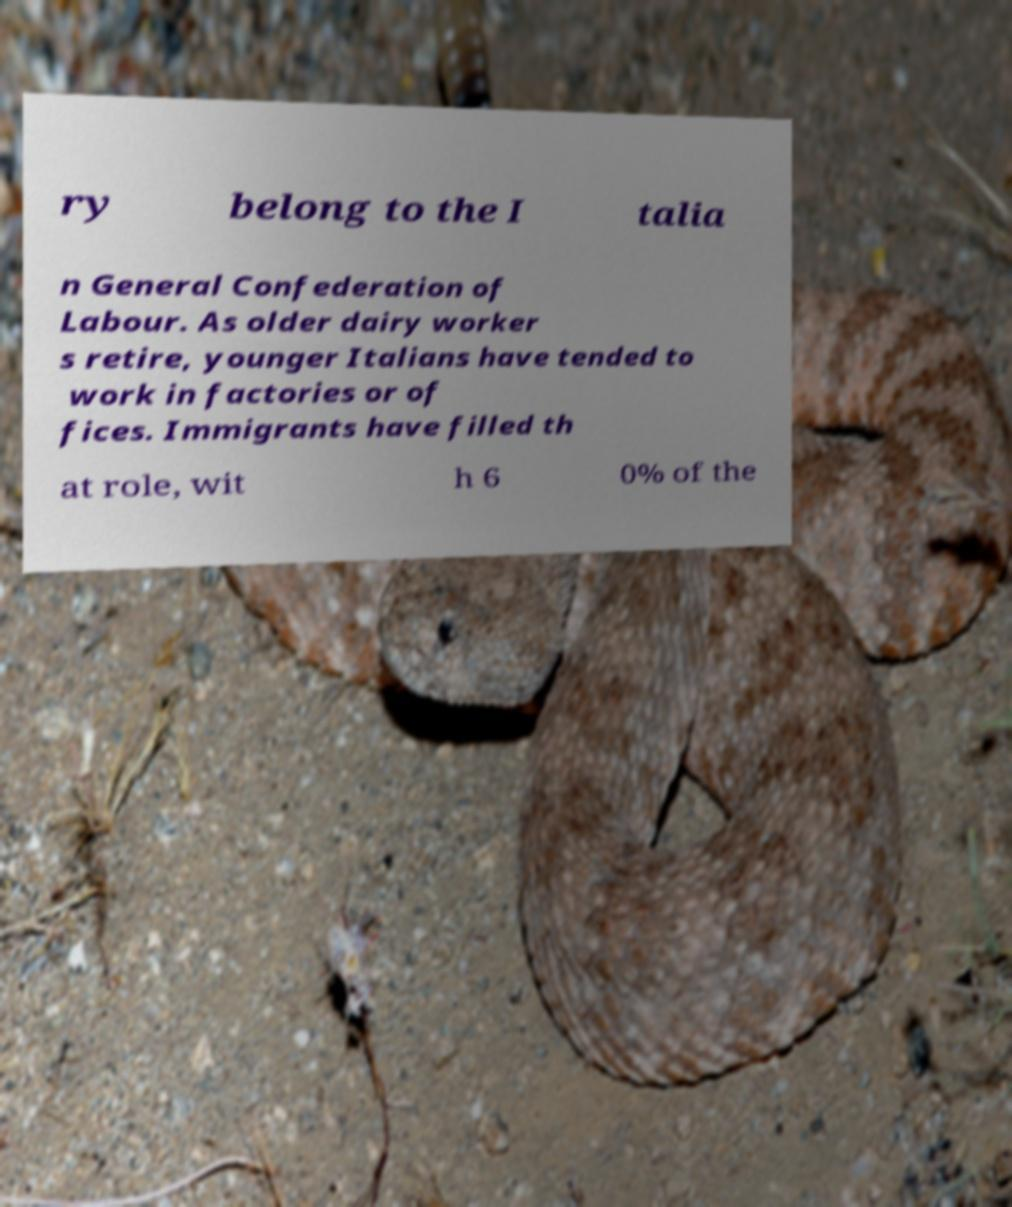Please read and relay the text visible in this image. What does it say? ry belong to the I talia n General Confederation of Labour. As older dairy worker s retire, younger Italians have tended to work in factories or of fices. Immigrants have filled th at role, wit h 6 0% of the 